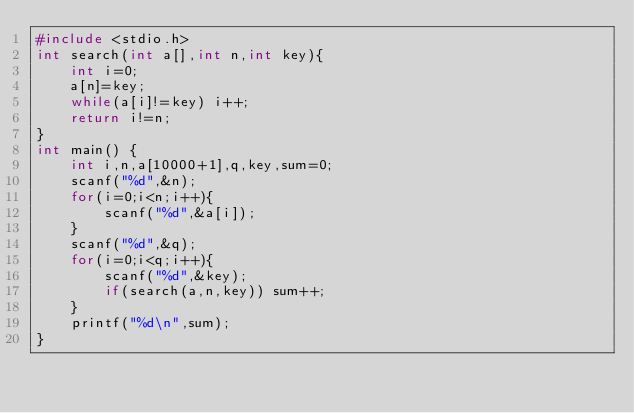Convert code to text. <code><loc_0><loc_0><loc_500><loc_500><_C_>#include <stdio.h>
int search(int a[],int n,int key){
    int i=0;
    a[n]=key;
    while(a[i]!=key) i++;
    return i!=n;
}
int main() {
    int i,n,a[10000+1],q,key,sum=0;
    scanf("%d",&n);
    for(i=0;i<n;i++){
        scanf("%d",&a[i]);
    }
    scanf("%d",&q);
    for(i=0;i<q;i++){
        scanf("%d",&key);
        if(search(a,n,key)) sum++;
    }
    printf("%d\n",sum);
}
</code> 